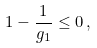Convert formula to latex. <formula><loc_0><loc_0><loc_500><loc_500>1 - \frac { 1 } { g _ { 1 } } \leq 0 \, ,</formula> 